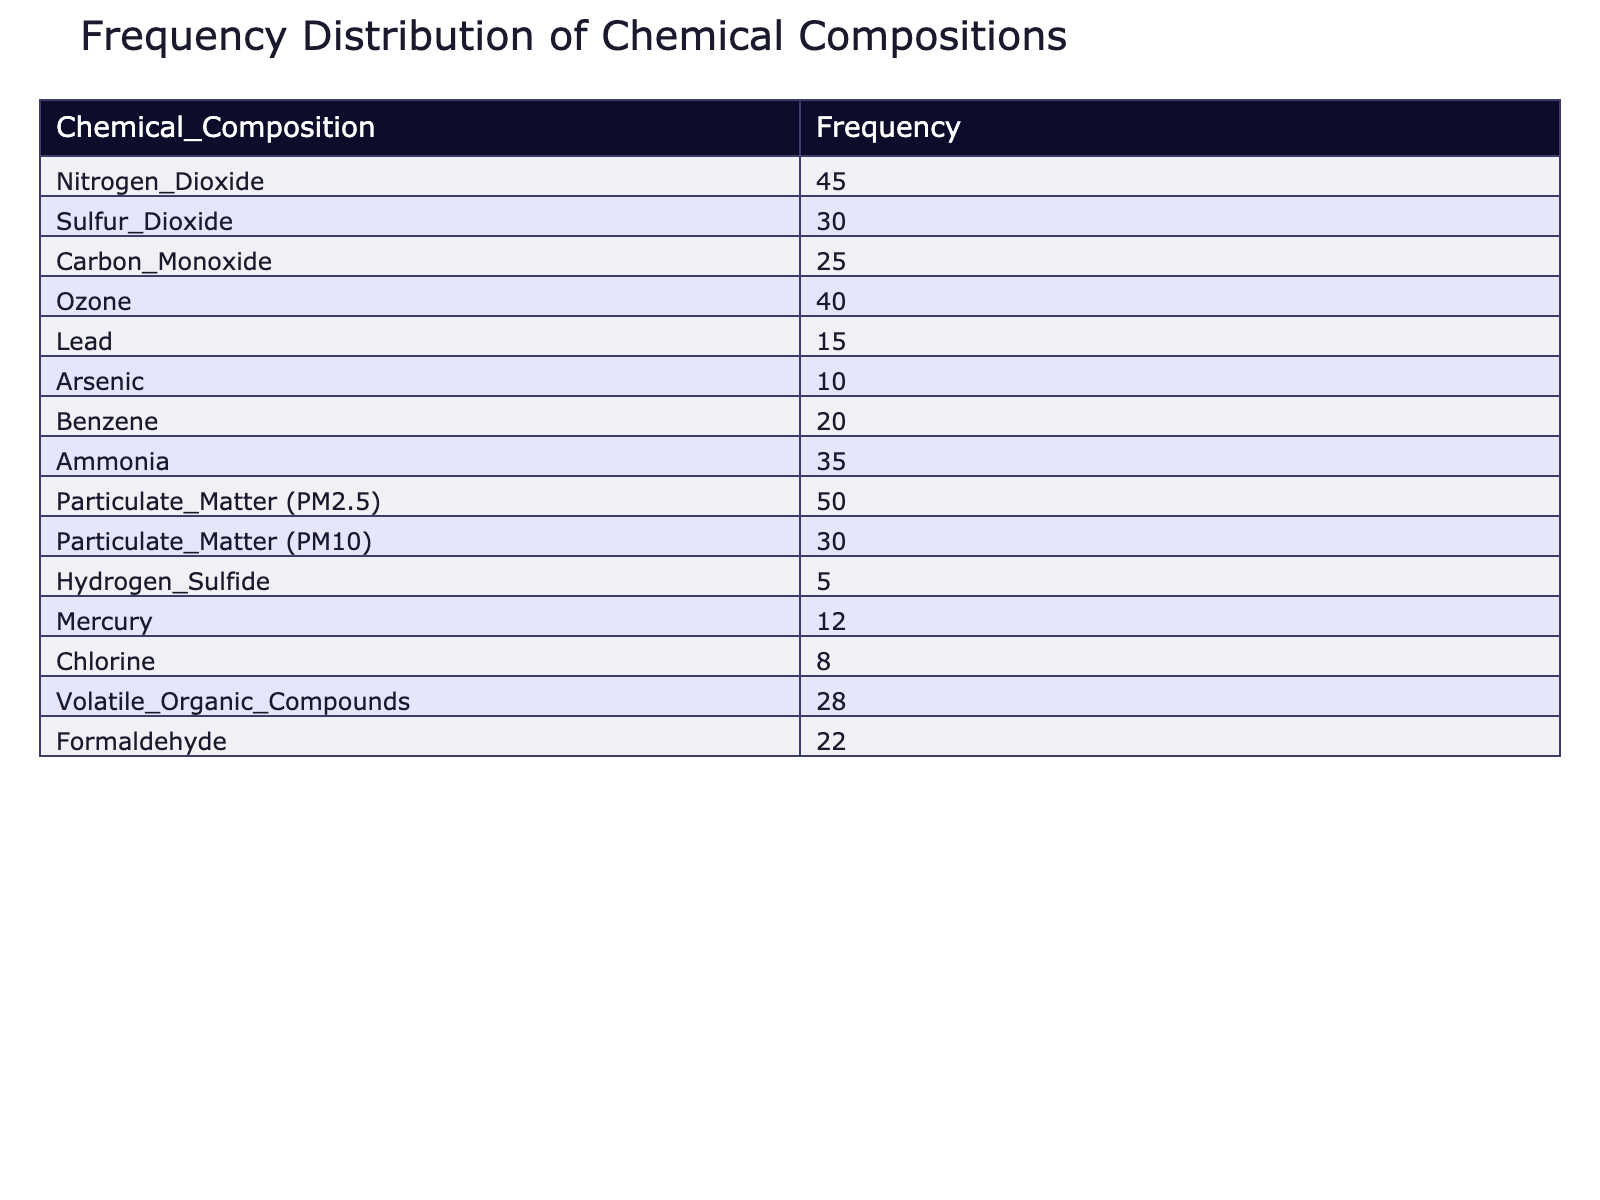What is the frequency of Nitrogen Dioxide? The table lists the frequency of Nitrogen Dioxide directly, showing it as 45.
Answer: 45 What is the frequency of Particulate Matter (PM2.5)? According to the table, the frequency for Particulate Matter (PM2.5) is provided as 50.
Answer: 50 Is the frequency of Mercury greater than that of Hydrogen Sulfide? The frequency for Mercury is 12, while for Hydrogen Sulfide it is 5. Since 12 is greater than 5, the statement is true.
Answer: Yes What is the total frequency of all the chemical compositions listed? Adding up the frequencies from all the chemical compositions: 45 + 30 + 25 + 40 + 15 + 10 + 20 + 35 + 50 + 30 + 5 + 12 + 8 + 28 + 22 =  450.
Answer: 450 Which chemical composition has the lowest frequency, and what is that frequency? The table shows that Hydrogen Sulfide has the lowest frequency value at 5.
Answer: Hydrogen Sulfide, 5 What is the average frequency of the chemical compositions listed in the table? There are 15 chemical compositions in total. The total frequency calculated is 450. The average is found by dividing the total frequency by the number of compositions: 450 / 15 = 30.
Answer: 30 Is the frequency of Ozone greater than the frequency of Ammonia? The frequency of Ozone is 40, while the frequency of Ammonia is 35. This indicates that 40 is greater than 35, making the statement true.
Answer: Yes What is the difference in frequency between the highest and lowest frequency chemical compositions? The highest frequency is for Particulate Matter (PM2.5) at 50 and the lowest is for Hydrogen Sulfide at 5. The difference is calculated as 50 - 5 = 45.
Answer: 45 Which two chemical compositions have frequencies that sum up to 80? Inspecting the frequencies, Ozone (40) and Ammonia (35) sum up to 75, while Particulate Matter (PM2.5) (50) and Benzene (20) sum to 70, thus no two compositions from the list sum to 80.
Answer: No 